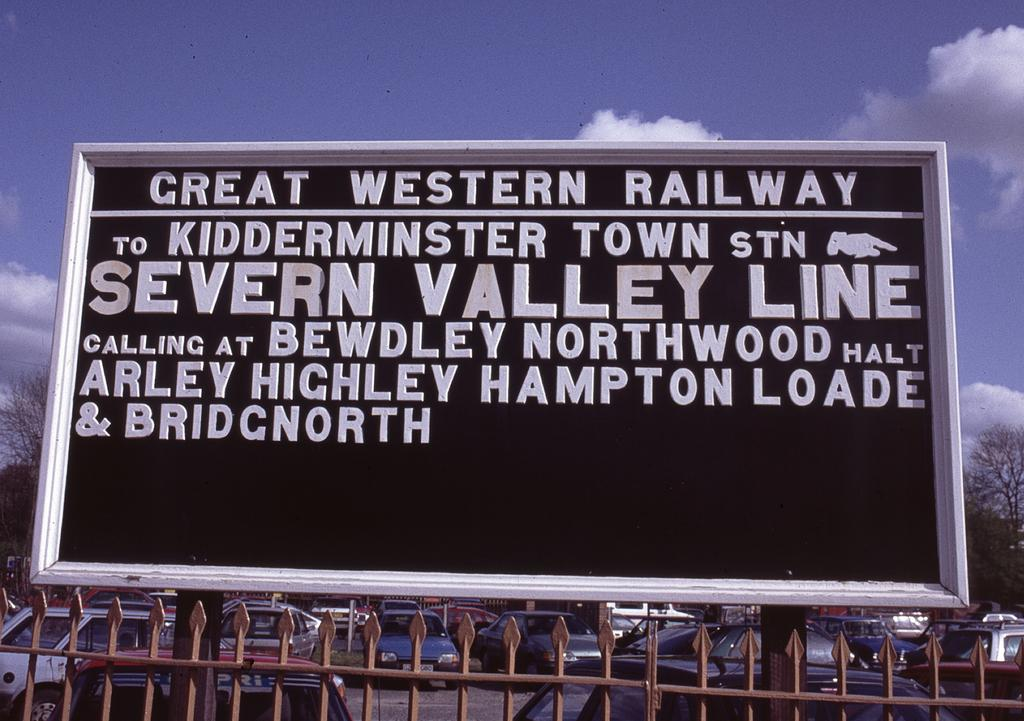<image>
Describe the image concisely. A Great Western Railway sign contains information about the Severn Valley Line. 